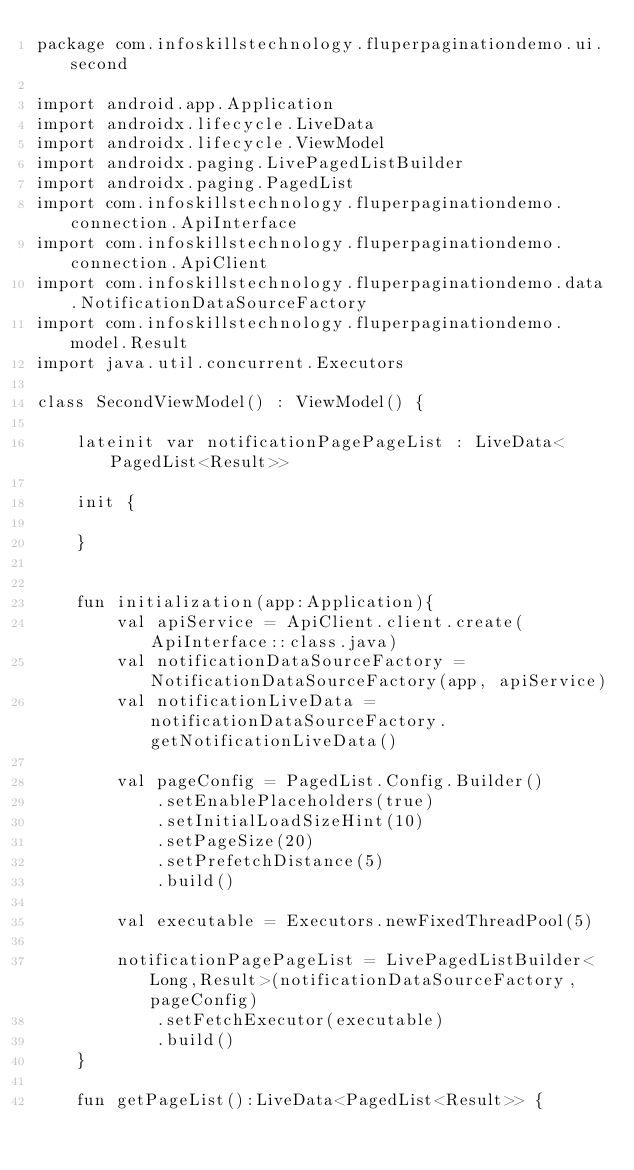<code> <loc_0><loc_0><loc_500><loc_500><_Kotlin_>package com.infoskillstechnology.fluperpaginationdemo.ui.second

import android.app.Application
import androidx.lifecycle.LiveData
import androidx.lifecycle.ViewModel
import androidx.paging.LivePagedListBuilder
import androidx.paging.PagedList
import com.infoskillstechnology.fluperpaginationdemo.connection.ApiInterface
import com.infoskillstechnology.fluperpaginationdemo.connection.ApiClient
import com.infoskillstechnology.fluperpaginationdemo.data.NotificationDataSourceFactory
import com.infoskillstechnology.fluperpaginationdemo.model.Result
import java.util.concurrent.Executors

class SecondViewModel() : ViewModel() {

    lateinit var notificationPagePageList : LiveData<PagedList<Result>>

    init {

    }


    fun initialization(app:Application){
        val apiService = ApiClient.client.create(ApiInterface::class.java)
        val notificationDataSourceFactory =  NotificationDataSourceFactory(app, apiService)
        val notificationLiveData =  notificationDataSourceFactory.getNotificationLiveData()

        val pageConfig = PagedList.Config.Builder()
            .setEnablePlaceholders(true)
            .setInitialLoadSizeHint(10)
            .setPageSize(20)
            .setPrefetchDistance(5)
            .build()

        val executable = Executors.newFixedThreadPool(5)

        notificationPagePageList = LivePagedListBuilder<Long,Result>(notificationDataSourceFactory, pageConfig)
            .setFetchExecutor(executable)
            .build()
    }

    fun getPageList():LiveData<PagedList<Result>> {</code> 